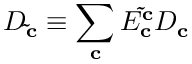<formula> <loc_0><loc_0><loc_500><loc_500>D _ { \tilde { c } } \equiv \sum _ { c } E _ { c } ^ { \tilde { c } } D _ { c }</formula> 